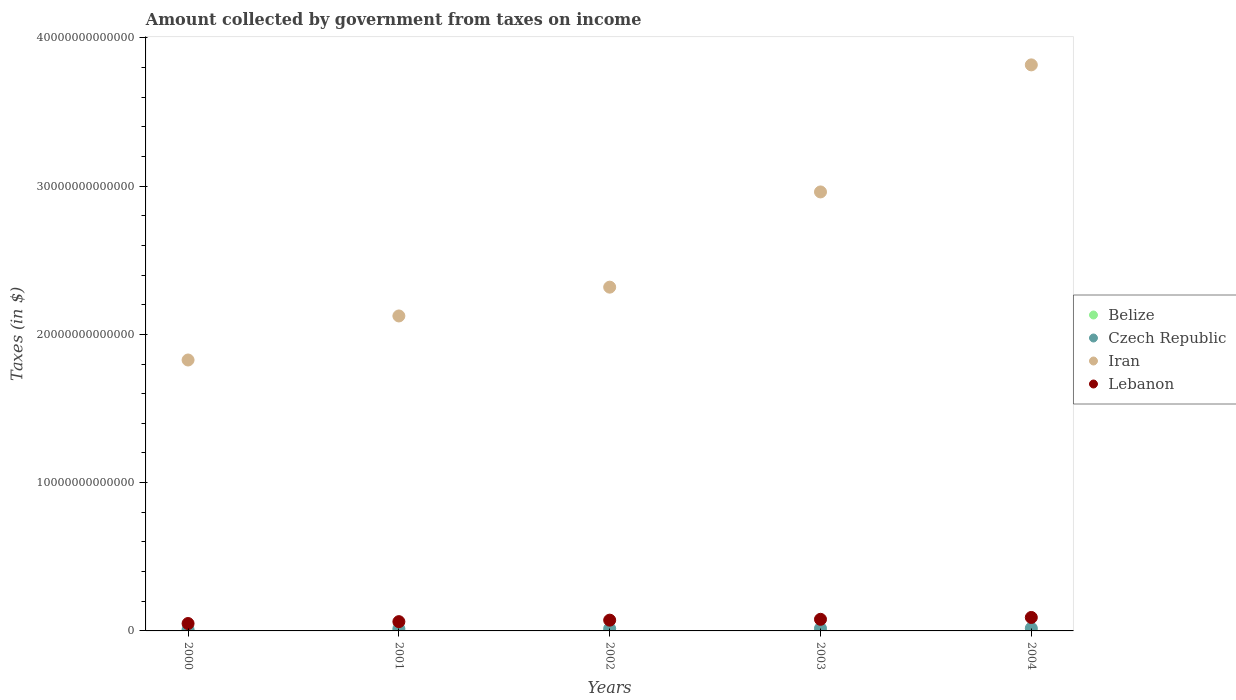Is the number of dotlines equal to the number of legend labels?
Provide a succinct answer. Yes. What is the amount collected by government from taxes on income in Czech Republic in 2000?
Ensure brevity in your answer.  8.71e+1. Across all years, what is the maximum amount collected by government from taxes on income in Iran?
Offer a very short reply. 3.82e+13. Across all years, what is the minimum amount collected by government from taxes on income in Lebanon?
Your answer should be very brief. 4.99e+11. In which year was the amount collected by government from taxes on income in Czech Republic maximum?
Your answer should be compact. 2004. What is the total amount collected by government from taxes on income in Lebanon in the graph?
Provide a short and direct response. 3.54e+12. What is the difference between the amount collected by government from taxes on income in Iran in 2001 and that in 2003?
Provide a short and direct response. -8.36e+12. What is the difference between the amount collected by government from taxes on income in Belize in 2002 and the amount collected by government from taxes on income in Iran in 2003?
Provide a short and direct response. -2.96e+13. What is the average amount collected by government from taxes on income in Belize per year?
Make the answer very short. 8.42e+07. In the year 2000, what is the difference between the amount collected by government from taxes on income in Iran and amount collected by government from taxes on income in Belize?
Offer a terse response. 1.83e+13. What is the ratio of the amount collected by government from taxes on income in Iran in 2003 to that in 2004?
Your answer should be very brief. 0.78. Is the amount collected by government from taxes on income in Belize in 2001 less than that in 2004?
Keep it short and to the point. Yes. What is the difference between the highest and the second highest amount collected by government from taxes on income in Belize?
Offer a very short reply. 1.07e+07. What is the difference between the highest and the lowest amount collected by government from taxes on income in Lebanon?
Provide a short and direct response. 4.09e+11. In how many years, is the amount collected by government from taxes on income in Iran greater than the average amount collected by government from taxes on income in Iran taken over all years?
Offer a very short reply. 2. Is it the case that in every year, the sum of the amount collected by government from taxes on income in Belize and amount collected by government from taxes on income in Czech Republic  is greater than the amount collected by government from taxes on income in Lebanon?
Offer a terse response. No. Does the amount collected by government from taxes on income in Czech Republic monotonically increase over the years?
Your answer should be compact. Yes. Is the amount collected by government from taxes on income in Czech Republic strictly less than the amount collected by government from taxes on income in Belize over the years?
Your response must be concise. No. How many dotlines are there?
Ensure brevity in your answer.  4. How many years are there in the graph?
Offer a very short reply. 5. What is the difference between two consecutive major ticks on the Y-axis?
Make the answer very short. 1.00e+13. Where does the legend appear in the graph?
Offer a terse response. Center right. How are the legend labels stacked?
Your answer should be compact. Vertical. What is the title of the graph?
Provide a succinct answer. Amount collected by government from taxes on income. Does "Haiti" appear as one of the legend labels in the graph?
Offer a terse response. No. What is the label or title of the Y-axis?
Your answer should be compact. Taxes (in $). What is the Taxes (in $) in Belize in 2000?
Offer a very short reply. 7.63e+07. What is the Taxes (in $) in Czech Republic in 2000?
Provide a succinct answer. 8.71e+1. What is the Taxes (in $) in Iran in 2000?
Offer a terse response. 1.83e+13. What is the Taxes (in $) of Lebanon in 2000?
Give a very brief answer. 4.99e+11. What is the Taxes (in $) in Belize in 2001?
Give a very brief answer. 7.70e+07. What is the Taxes (in $) of Czech Republic in 2001?
Ensure brevity in your answer.  1.47e+11. What is the Taxes (in $) of Iran in 2001?
Keep it short and to the point. 2.12e+13. What is the Taxes (in $) in Lebanon in 2001?
Ensure brevity in your answer.  6.26e+11. What is the Taxes (in $) in Belize in 2002?
Your answer should be compact. 7.89e+07. What is the Taxes (in $) of Czech Republic in 2002?
Make the answer very short. 1.59e+11. What is the Taxes (in $) of Iran in 2002?
Ensure brevity in your answer.  2.32e+13. What is the Taxes (in $) in Lebanon in 2002?
Keep it short and to the point. 7.27e+11. What is the Taxes (in $) in Belize in 2003?
Offer a terse response. 8.91e+07. What is the Taxes (in $) of Czech Republic in 2003?
Your response must be concise. 1.73e+11. What is the Taxes (in $) of Iran in 2003?
Your response must be concise. 2.96e+13. What is the Taxes (in $) of Lebanon in 2003?
Ensure brevity in your answer.  7.83e+11. What is the Taxes (in $) in Belize in 2004?
Your answer should be compact. 9.98e+07. What is the Taxes (in $) in Czech Republic in 2004?
Give a very brief answer. 1.81e+11. What is the Taxes (in $) in Iran in 2004?
Make the answer very short. 3.82e+13. What is the Taxes (in $) in Lebanon in 2004?
Make the answer very short. 9.08e+11. Across all years, what is the maximum Taxes (in $) in Belize?
Your response must be concise. 9.98e+07. Across all years, what is the maximum Taxes (in $) of Czech Republic?
Make the answer very short. 1.81e+11. Across all years, what is the maximum Taxes (in $) of Iran?
Provide a short and direct response. 3.82e+13. Across all years, what is the maximum Taxes (in $) of Lebanon?
Your response must be concise. 9.08e+11. Across all years, what is the minimum Taxes (in $) of Belize?
Your answer should be very brief. 7.63e+07. Across all years, what is the minimum Taxes (in $) of Czech Republic?
Your answer should be compact. 8.71e+1. Across all years, what is the minimum Taxes (in $) in Iran?
Offer a very short reply. 1.83e+13. Across all years, what is the minimum Taxes (in $) of Lebanon?
Keep it short and to the point. 4.99e+11. What is the total Taxes (in $) of Belize in the graph?
Your response must be concise. 4.21e+08. What is the total Taxes (in $) of Czech Republic in the graph?
Provide a short and direct response. 7.47e+11. What is the total Taxes (in $) of Iran in the graph?
Offer a very short reply. 1.30e+14. What is the total Taxes (in $) of Lebanon in the graph?
Your response must be concise. 3.54e+12. What is the difference between the Taxes (in $) in Belize in 2000 and that in 2001?
Your answer should be very brief. -6.67e+05. What is the difference between the Taxes (in $) in Czech Republic in 2000 and that in 2001?
Give a very brief answer. -6.03e+1. What is the difference between the Taxes (in $) of Iran in 2000 and that in 2001?
Make the answer very short. -2.97e+12. What is the difference between the Taxes (in $) in Lebanon in 2000 and that in 2001?
Offer a very short reply. -1.27e+11. What is the difference between the Taxes (in $) of Belize in 2000 and that in 2002?
Your answer should be compact. -2.63e+06. What is the difference between the Taxes (in $) of Czech Republic in 2000 and that in 2002?
Your answer should be very brief. -7.19e+1. What is the difference between the Taxes (in $) in Iran in 2000 and that in 2002?
Give a very brief answer. -4.91e+12. What is the difference between the Taxes (in $) in Lebanon in 2000 and that in 2002?
Your answer should be compact. -2.28e+11. What is the difference between the Taxes (in $) of Belize in 2000 and that in 2003?
Provide a succinct answer. -1.28e+07. What is the difference between the Taxes (in $) in Czech Republic in 2000 and that in 2003?
Your answer should be very brief. -8.58e+1. What is the difference between the Taxes (in $) in Iran in 2000 and that in 2003?
Your answer should be very brief. -1.13e+13. What is the difference between the Taxes (in $) in Lebanon in 2000 and that in 2003?
Provide a short and direct response. -2.84e+11. What is the difference between the Taxes (in $) in Belize in 2000 and that in 2004?
Your answer should be very brief. -2.35e+07. What is the difference between the Taxes (in $) of Czech Republic in 2000 and that in 2004?
Keep it short and to the point. -9.36e+1. What is the difference between the Taxes (in $) in Iran in 2000 and that in 2004?
Keep it short and to the point. -1.99e+13. What is the difference between the Taxes (in $) of Lebanon in 2000 and that in 2004?
Provide a short and direct response. -4.09e+11. What is the difference between the Taxes (in $) in Belize in 2001 and that in 2002?
Your answer should be compact. -1.96e+06. What is the difference between the Taxes (in $) in Czech Republic in 2001 and that in 2002?
Ensure brevity in your answer.  -1.16e+1. What is the difference between the Taxes (in $) of Iran in 2001 and that in 2002?
Your answer should be very brief. -1.94e+12. What is the difference between the Taxes (in $) in Lebanon in 2001 and that in 2002?
Your response must be concise. -1.01e+11. What is the difference between the Taxes (in $) of Belize in 2001 and that in 2003?
Provide a short and direct response. -1.21e+07. What is the difference between the Taxes (in $) in Czech Republic in 2001 and that in 2003?
Keep it short and to the point. -2.55e+1. What is the difference between the Taxes (in $) of Iran in 2001 and that in 2003?
Make the answer very short. -8.36e+12. What is the difference between the Taxes (in $) of Lebanon in 2001 and that in 2003?
Give a very brief answer. -1.57e+11. What is the difference between the Taxes (in $) in Belize in 2001 and that in 2004?
Your answer should be very brief. -2.28e+07. What is the difference between the Taxes (in $) in Czech Republic in 2001 and that in 2004?
Make the answer very short. -3.33e+1. What is the difference between the Taxes (in $) of Iran in 2001 and that in 2004?
Offer a very short reply. -1.69e+13. What is the difference between the Taxes (in $) in Lebanon in 2001 and that in 2004?
Provide a succinct answer. -2.82e+11. What is the difference between the Taxes (in $) of Belize in 2002 and that in 2003?
Make the answer very short. -1.02e+07. What is the difference between the Taxes (in $) of Czech Republic in 2002 and that in 2003?
Provide a succinct answer. -1.39e+1. What is the difference between the Taxes (in $) of Iran in 2002 and that in 2003?
Your answer should be very brief. -6.42e+12. What is the difference between the Taxes (in $) in Lebanon in 2002 and that in 2003?
Provide a succinct answer. -5.66e+1. What is the difference between the Taxes (in $) of Belize in 2002 and that in 2004?
Your response must be concise. -2.09e+07. What is the difference between the Taxes (in $) of Czech Republic in 2002 and that in 2004?
Provide a short and direct response. -2.17e+1. What is the difference between the Taxes (in $) in Iran in 2002 and that in 2004?
Your response must be concise. -1.50e+13. What is the difference between the Taxes (in $) of Lebanon in 2002 and that in 2004?
Keep it short and to the point. -1.81e+11. What is the difference between the Taxes (in $) in Belize in 2003 and that in 2004?
Your answer should be compact. -1.07e+07. What is the difference between the Taxes (in $) in Czech Republic in 2003 and that in 2004?
Your response must be concise. -7.83e+09. What is the difference between the Taxes (in $) in Iran in 2003 and that in 2004?
Make the answer very short. -8.57e+12. What is the difference between the Taxes (in $) in Lebanon in 2003 and that in 2004?
Ensure brevity in your answer.  -1.25e+11. What is the difference between the Taxes (in $) of Belize in 2000 and the Taxes (in $) of Czech Republic in 2001?
Your answer should be compact. -1.47e+11. What is the difference between the Taxes (in $) in Belize in 2000 and the Taxes (in $) in Iran in 2001?
Offer a very short reply. -2.12e+13. What is the difference between the Taxes (in $) of Belize in 2000 and the Taxes (in $) of Lebanon in 2001?
Your answer should be compact. -6.26e+11. What is the difference between the Taxes (in $) of Czech Republic in 2000 and the Taxes (in $) of Iran in 2001?
Provide a succinct answer. -2.12e+13. What is the difference between the Taxes (in $) of Czech Republic in 2000 and the Taxes (in $) of Lebanon in 2001?
Give a very brief answer. -5.39e+11. What is the difference between the Taxes (in $) of Iran in 2000 and the Taxes (in $) of Lebanon in 2001?
Offer a terse response. 1.76e+13. What is the difference between the Taxes (in $) in Belize in 2000 and the Taxes (in $) in Czech Republic in 2002?
Your answer should be compact. -1.59e+11. What is the difference between the Taxes (in $) in Belize in 2000 and the Taxes (in $) in Iran in 2002?
Your answer should be compact. -2.32e+13. What is the difference between the Taxes (in $) in Belize in 2000 and the Taxes (in $) in Lebanon in 2002?
Provide a short and direct response. -7.27e+11. What is the difference between the Taxes (in $) of Czech Republic in 2000 and the Taxes (in $) of Iran in 2002?
Your response must be concise. -2.31e+13. What is the difference between the Taxes (in $) in Czech Republic in 2000 and the Taxes (in $) in Lebanon in 2002?
Ensure brevity in your answer.  -6.40e+11. What is the difference between the Taxes (in $) of Iran in 2000 and the Taxes (in $) of Lebanon in 2002?
Make the answer very short. 1.75e+13. What is the difference between the Taxes (in $) in Belize in 2000 and the Taxes (in $) in Czech Republic in 2003?
Keep it short and to the point. -1.73e+11. What is the difference between the Taxes (in $) of Belize in 2000 and the Taxes (in $) of Iran in 2003?
Make the answer very short. -2.96e+13. What is the difference between the Taxes (in $) in Belize in 2000 and the Taxes (in $) in Lebanon in 2003?
Ensure brevity in your answer.  -7.83e+11. What is the difference between the Taxes (in $) of Czech Republic in 2000 and the Taxes (in $) of Iran in 2003?
Offer a terse response. -2.95e+13. What is the difference between the Taxes (in $) in Czech Republic in 2000 and the Taxes (in $) in Lebanon in 2003?
Offer a terse response. -6.96e+11. What is the difference between the Taxes (in $) in Iran in 2000 and the Taxes (in $) in Lebanon in 2003?
Your answer should be very brief. 1.75e+13. What is the difference between the Taxes (in $) of Belize in 2000 and the Taxes (in $) of Czech Republic in 2004?
Offer a very short reply. -1.81e+11. What is the difference between the Taxes (in $) in Belize in 2000 and the Taxes (in $) in Iran in 2004?
Offer a terse response. -3.82e+13. What is the difference between the Taxes (in $) in Belize in 2000 and the Taxes (in $) in Lebanon in 2004?
Your response must be concise. -9.08e+11. What is the difference between the Taxes (in $) in Czech Republic in 2000 and the Taxes (in $) in Iran in 2004?
Make the answer very short. -3.81e+13. What is the difference between the Taxes (in $) in Czech Republic in 2000 and the Taxes (in $) in Lebanon in 2004?
Your response must be concise. -8.21e+11. What is the difference between the Taxes (in $) of Iran in 2000 and the Taxes (in $) of Lebanon in 2004?
Give a very brief answer. 1.74e+13. What is the difference between the Taxes (in $) of Belize in 2001 and the Taxes (in $) of Czech Republic in 2002?
Keep it short and to the point. -1.59e+11. What is the difference between the Taxes (in $) in Belize in 2001 and the Taxes (in $) in Iran in 2002?
Offer a very short reply. -2.32e+13. What is the difference between the Taxes (in $) in Belize in 2001 and the Taxes (in $) in Lebanon in 2002?
Give a very brief answer. -7.27e+11. What is the difference between the Taxes (in $) in Czech Republic in 2001 and the Taxes (in $) in Iran in 2002?
Provide a succinct answer. -2.30e+13. What is the difference between the Taxes (in $) of Czech Republic in 2001 and the Taxes (in $) of Lebanon in 2002?
Your response must be concise. -5.79e+11. What is the difference between the Taxes (in $) in Iran in 2001 and the Taxes (in $) in Lebanon in 2002?
Provide a short and direct response. 2.05e+13. What is the difference between the Taxes (in $) of Belize in 2001 and the Taxes (in $) of Czech Republic in 2003?
Provide a short and direct response. -1.73e+11. What is the difference between the Taxes (in $) of Belize in 2001 and the Taxes (in $) of Iran in 2003?
Provide a succinct answer. -2.96e+13. What is the difference between the Taxes (in $) of Belize in 2001 and the Taxes (in $) of Lebanon in 2003?
Give a very brief answer. -7.83e+11. What is the difference between the Taxes (in $) in Czech Republic in 2001 and the Taxes (in $) in Iran in 2003?
Give a very brief answer. -2.95e+13. What is the difference between the Taxes (in $) of Czech Republic in 2001 and the Taxes (in $) of Lebanon in 2003?
Offer a very short reply. -6.36e+11. What is the difference between the Taxes (in $) of Iran in 2001 and the Taxes (in $) of Lebanon in 2003?
Make the answer very short. 2.05e+13. What is the difference between the Taxes (in $) in Belize in 2001 and the Taxes (in $) in Czech Republic in 2004?
Your answer should be compact. -1.81e+11. What is the difference between the Taxes (in $) of Belize in 2001 and the Taxes (in $) of Iran in 2004?
Provide a succinct answer. -3.82e+13. What is the difference between the Taxes (in $) of Belize in 2001 and the Taxes (in $) of Lebanon in 2004?
Provide a short and direct response. -9.08e+11. What is the difference between the Taxes (in $) of Czech Republic in 2001 and the Taxes (in $) of Iran in 2004?
Your response must be concise. -3.80e+13. What is the difference between the Taxes (in $) of Czech Republic in 2001 and the Taxes (in $) of Lebanon in 2004?
Give a very brief answer. -7.61e+11. What is the difference between the Taxes (in $) of Iran in 2001 and the Taxes (in $) of Lebanon in 2004?
Your response must be concise. 2.03e+13. What is the difference between the Taxes (in $) of Belize in 2002 and the Taxes (in $) of Czech Republic in 2003?
Provide a short and direct response. -1.73e+11. What is the difference between the Taxes (in $) in Belize in 2002 and the Taxes (in $) in Iran in 2003?
Offer a terse response. -2.96e+13. What is the difference between the Taxes (in $) in Belize in 2002 and the Taxes (in $) in Lebanon in 2003?
Keep it short and to the point. -7.83e+11. What is the difference between the Taxes (in $) of Czech Republic in 2002 and the Taxes (in $) of Iran in 2003?
Your response must be concise. -2.94e+13. What is the difference between the Taxes (in $) in Czech Republic in 2002 and the Taxes (in $) in Lebanon in 2003?
Keep it short and to the point. -6.24e+11. What is the difference between the Taxes (in $) in Iran in 2002 and the Taxes (in $) in Lebanon in 2003?
Your answer should be very brief. 2.24e+13. What is the difference between the Taxes (in $) of Belize in 2002 and the Taxes (in $) of Czech Republic in 2004?
Your answer should be compact. -1.81e+11. What is the difference between the Taxes (in $) in Belize in 2002 and the Taxes (in $) in Iran in 2004?
Offer a very short reply. -3.82e+13. What is the difference between the Taxes (in $) of Belize in 2002 and the Taxes (in $) of Lebanon in 2004?
Ensure brevity in your answer.  -9.08e+11. What is the difference between the Taxes (in $) of Czech Republic in 2002 and the Taxes (in $) of Iran in 2004?
Your answer should be very brief. -3.80e+13. What is the difference between the Taxes (in $) of Czech Republic in 2002 and the Taxes (in $) of Lebanon in 2004?
Your answer should be compact. -7.49e+11. What is the difference between the Taxes (in $) in Iran in 2002 and the Taxes (in $) in Lebanon in 2004?
Your response must be concise. 2.23e+13. What is the difference between the Taxes (in $) of Belize in 2003 and the Taxes (in $) of Czech Republic in 2004?
Provide a succinct answer. -1.81e+11. What is the difference between the Taxes (in $) of Belize in 2003 and the Taxes (in $) of Iran in 2004?
Keep it short and to the point. -3.82e+13. What is the difference between the Taxes (in $) of Belize in 2003 and the Taxes (in $) of Lebanon in 2004?
Ensure brevity in your answer.  -9.08e+11. What is the difference between the Taxes (in $) of Czech Republic in 2003 and the Taxes (in $) of Iran in 2004?
Provide a succinct answer. -3.80e+13. What is the difference between the Taxes (in $) in Czech Republic in 2003 and the Taxes (in $) in Lebanon in 2004?
Provide a succinct answer. -7.35e+11. What is the difference between the Taxes (in $) of Iran in 2003 and the Taxes (in $) of Lebanon in 2004?
Your answer should be very brief. 2.87e+13. What is the average Taxes (in $) in Belize per year?
Provide a succinct answer. 8.42e+07. What is the average Taxes (in $) of Czech Republic per year?
Make the answer very short. 1.49e+11. What is the average Taxes (in $) in Iran per year?
Make the answer very short. 2.61e+13. What is the average Taxes (in $) of Lebanon per year?
Provide a succinct answer. 7.09e+11. In the year 2000, what is the difference between the Taxes (in $) of Belize and Taxes (in $) of Czech Republic?
Offer a very short reply. -8.70e+1. In the year 2000, what is the difference between the Taxes (in $) in Belize and Taxes (in $) in Iran?
Keep it short and to the point. -1.83e+13. In the year 2000, what is the difference between the Taxes (in $) in Belize and Taxes (in $) in Lebanon?
Your answer should be compact. -4.99e+11. In the year 2000, what is the difference between the Taxes (in $) of Czech Republic and Taxes (in $) of Iran?
Give a very brief answer. -1.82e+13. In the year 2000, what is the difference between the Taxes (in $) in Czech Republic and Taxes (in $) in Lebanon?
Offer a terse response. -4.12e+11. In the year 2000, what is the difference between the Taxes (in $) in Iran and Taxes (in $) in Lebanon?
Provide a succinct answer. 1.78e+13. In the year 2001, what is the difference between the Taxes (in $) in Belize and Taxes (in $) in Czech Republic?
Ensure brevity in your answer.  -1.47e+11. In the year 2001, what is the difference between the Taxes (in $) of Belize and Taxes (in $) of Iran?
Provide a succinct answer. -2.12e+13. In the year 2001, what is the difference between the Taxes (in $) in Belize and Taxes (in $) in Lebanon?
Ensure brevity in your answer.  -6.26e+11. In the year 2001, what is the difference between the Taxes (in $) in Czech Republic and Taxes (in $) in Iran?
Offer a terse response. -2.11e+13. In the year 2001, what is the difference between the Taxes (in $) of Czech Republic and Taxes (in $) of Lebanon?
Your response must be concise. -4.79e+11. In the year 2001, what is the difference between the Taxes (in $) of Iran and Taxes (in $) of Lebanon?
Your response must be concise. 2.06e+13. In the year 2002, what is the difference between the Taxes (in $) in Belize and Taxes (in $) in Czech Republic?
Give a very brief answer. -1.59e+11. In the year 2002, what is the difference between the Taxes (in $) of Belize and Taxes (in $) of Iran?
Your answer should be compact. -2.32e+13. In the year 2002, what is the difference between the Taxes (in $) in Belize and Taxes (in $) in Lebanon?
Offer a terse response. -7.27e+11. In the year 2002, what is the difference between the Taxes (in $) of Czech Republic and Taxes (in $) of Iran?
Your answer should be very brief. -2.30e+13. In the year 2002, what is the difference between the Taxes (in $) of Czech Republic and Taxes (in $) of Lebanon?
Your answer should be compact. -5.68e+11. In the year 2002, what is the difference between the Taxes (in $) in Iran and Taxes (in $) in Lebanon?
Keep it short and to the point. 2.25e+13. In the year 2003, what is the difference between the Taxes (in $) of Belize and Taxes (in $) of Czech Republic?
Offer a very short reply. -1.73e+11. In the year 2003, what is the difference between the Taxes (in $) in Belize and Taxes (in $) in Iran?
Ensure brevity in your answer.  -2.96e+13. In the year 2003, what is the difference between the Taxes (in $) in Belize and Taxes (in $) in Lebanon?
Offer a terse response. -7.83e+11. In the year 2003, what is the difference between the Taxes (in $) of Czech Republic and Taxes (in $) of Iran?
Your response must be concise. -2.94e+13. In the year 2003, what is the difference between the Taxes (in $) of Czech Republic and Taxes (in $) of Lebanon?
Your answer should be compact. -6.10e+11. In the year 2003, what is the difference between the Taxes (in $) of Iran and Taxes (in $) of Lebanon?
Give a very brief answer. 2.88e+13. In the year 2004, what is the difference between the Taxes (in $) of Belize and Taxes (in $) of Czech Republic?
Ensure brevity in your answer.  -1.81e+11. In the year 2004, what is the difference between the Taxes (in $) in Belize and Taxes (in $) in Iran?
Keep it short and to the point. -3.82e+13. In the year 2004, what is the difference between the Taxes (in $) of Belize and Taxes (in $) of Lebanon?
Provide a short and direct response. -9.08e+11. In the year 2004, what is the difference between the Taxes (in $) in Czech Republic and Taxes (in $) in Iran?
Your response must be concise. -3.80e+13. In the year 2004, what is the difference between the Taxes (in $) in Czech Republic and Taxes (in $) in Lebanon?
Your answer should be very brief. -7.27e+11. In the year 2004, what is the difference between the Taxes (in $) in Iran and Taxes (in $) in Lebanon?
Ensure brevity in your answer.  3.73e+13. What is the ratio of the Taxes (in $) of Belize in 2000 to that in 2001?
Your answer should be compact. 0.99. What is the ratio of the Taxes (in $) in Czech Republic in 2000 to that in 2001?
Offer a terse response. 0.59. What is the ratio of the Taxes (in $) in Iran in 2000 to that in 2001?
Your response must be concise. 0.86. What is the ratio of the Taxes (in $) of Lebanon in 2000 to that in 2001?
Your answer should be compact. 0.8. What is the ratio of the Taxes (in $) in Belize in 2000 to that in 2002?
Provide a succinct answer. 0.97. What is the ratio of the Taxes (in $) in Czech Republic in 2000 to that in 2002?
Give a very brief answer. 0.55. What is the ratio of the Taxes (in $) of Iran in 2000 to that in 2002?
Offer a very short reply. 0.79. What is the ratio of the Taxes (in $) of Lebanon in 2000 to that in 2002?
Provide a succinct answer. 0.69. What is the ratio of the Taxes (in $) of Belize in 2000 to that in 2003?
Keep it short and to the point. 0.86. What is the ratio of the Taxes (in $) in Czech Republic in 2000 to that in 2003?
Your answer should be very brief. 0.5. What is the ratio of the Taxes (in $) in Iran in 2000 to that in 2003?
Make the answer very short. 0.62. What is the ratio of the Taxes (in $) of Lebanon in 2000 to that in 2003?
Your answer should be very brief. 0.64. What is the ratio of the Taxes (in $) in Belize in 2000 to that in 2004?
Offer a terse response. 0.76. What is the ratio of the Taxes (in $) in Czech Republic in 2000 to that in 2004?
Your answer should be very brief. 0.48. What is the ratio of the Taxes (in $) of Iran in 2000 to that in 2004?
Offer a very short reply. 0.48. What is the ratio of the Taxes (in $) in Lebanon in 2000 to that in 2004?
Provide a succinct answer. 0.55. What is the ratio of the Taxes (in $) of Belize in 2001 to that in 2002?
Ensure brevity in your answer.  0.98. What is the ratio of the Taxes (in $) of Czech Republic in 2001 to that in 2002?
Offer a terse response. 0.93. What is the ratio of the Taxes (in $) in Iran in 2001 to that in 2002?
Provide a short and direct response. 0.92. What is the ratio of the Taxes (in $) in Lebanon in 2001 to that in 2002?
Provide a short and direct response. 0.86. What is the ratio of the Taxes (in $) of Belize in 2001 to that in 2003?
Your answer should be compact. 0.86. What is the ratio of the Taxes (in $) of Czech Republic in 2001 to that in 2003?
Your answer should be compact. 0.85. What is the ratio of the Taxes (in $) in Iran in 2001 to that in 2003?
Make the answer very short. 0.72. What is the ratio of the Taxes (in $) of Lebanon in 2001 to that in 2003?
Provide a short and direct response. 0.8. What is the ratio of the Taxes (in $) of Belize in 2001 to that in 2004?
Ensure brevity in your answer.  0.77. What is the ratio of the Taxes (in $) of Czech Republic in 2001 to that in 2004?
Give a very brief answer. 0.82. What is the ratio of the Taxes (in $) of Iran in 2001 to that in 2004?
Your answer should be compact. 0.56. What is the ratio of the Taxes (in $) in Lebanon in 2001 to that in 2004?
Your answer should be very brief. 0.69. What is the ratio of the Taxes (in $) in Belize in 2002 to that in 2003?
Offer a very short reply. 0.89. What is the ratio of the Taxes (in $) in Czech Republic in 2002 to that in 2003?
Your answer should be compact. 0.92. What is the ratio of the Taxes (in $) in Iran in 2002 to that in 2003?
Make the answer very short. 0.78. What is the ratio of the Taxes (in $) of Lebanon in 2002 to that in 2003?
Provide a short and direct response. 0.93. What is the ratio of the Taxes (in $) in Belize in 2002 to that in 2004?
Provide a short and direct response. 0.79. What is the ratio of the Taxes (in $) of Czech Republic in 2002 to that in 2004?
Offer a very short reply. 0.88. What is the ratio of the Taxes (in $) in Iran in 2002 to that in 2004?
Your answer should be very brief. 0.61. What is the ratio of the Taxes (in $) in Lebanon in 2002 to that in 2004?
Your response must be concise. 0.8. What is the ratio of the Taxes (in $) of Belize in 2003 to that in 2004?
Offer a terse response. 0.89. What is the ratio of the Taxes (in $) of Czech Republic in 2003 to that in 2004?
Offer a very short reply. 0.96. What is the ratio of the Taxes (in $) of Iran in 2003 to that in 2004?
Give a very brief answer. 0.78. What is the ratio of the Taxes (in $) of Lebanon in 2003 to that in 2004?
Make the answer very short. 0.86. What is the difference between the highest and the second highest Taxes (in $) in Belize?
Offer a very short reply. 1.07e+07. What is the difference between the highest and the second highest Taxes (in $) in Czech Republic?
Give a very brief answer. 7.83e+09. What is the difference between the highest and the second highest Taxes (in $) of Iran?
Offer a very short reply. 8.57e+12. What is the difference between the highest and the second highest Taxes (in $) of Lebanon?
Give a very brief answer. 1.25e+11. What is the difference between the highest and the lowest Taxes (in $) of Belize?
Your answer should be compact. 2.35e+07. What is the difference between the highest and the lowest Taxes (in $) in Czech Republic?
Your response must be concise. 9.36e+1. What is the difference between the highest and the lowest Taxes (in $) in Iran?
Ensure brevity in your answer.  1.99e+13. What is the difference between the highest and the lowest Taxes (in $) in Lebanon?
Give a very brief answer. 4.09e+11. 